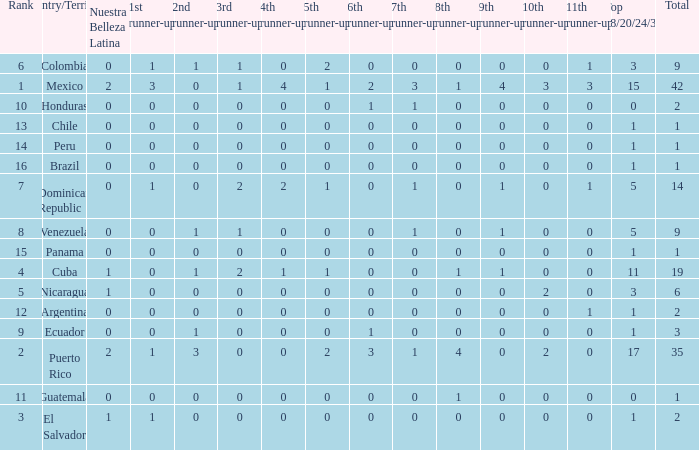What is the average total of the country with a 4th runner-up of 0 and a Nuestra Bellaza Latina less than 0? None. 